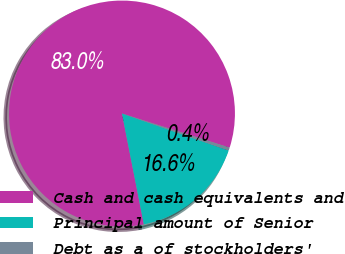Convert chart to OTSL. <chart><loc_0><loc_0><loc_500><loc_500><pie_chart><fcel>Cash and cash equivalents and<fcel>Principal amount of Senior<fcel>Debt as a of stockholders'<nl><fcel>82.98%<fcel>16.59%<fcel>0.43%<nl></chart> 